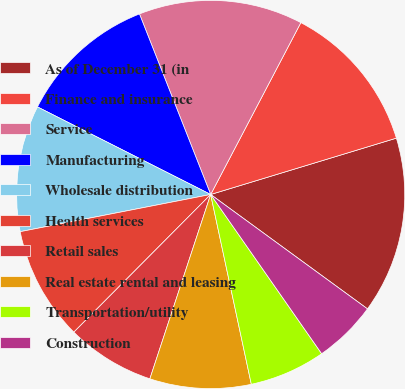Convert chart to OTSL. <chart><loc_0><loc_0><loc_500><loc_500><pie_chart><fcel>As of December 31 (in<fcel>Finance and insurance<fcel>Service<fcel>Manufacturing<fcel>Wholesale distribution<fcel>Health services<fcel>Retail sales<fcel>Real estate rental and leasing<fcel>Transportation/utility<fcel>Construction<nl><fcel>14.72%<fcel>12.62%<fcel>13.67%<fcel>11.57%<fcel>10.52%<fcel>9.48%<fcel>7.38%<fcel>8.43%<fcel>6.33%<fcel>5.28%<nl></chart> 